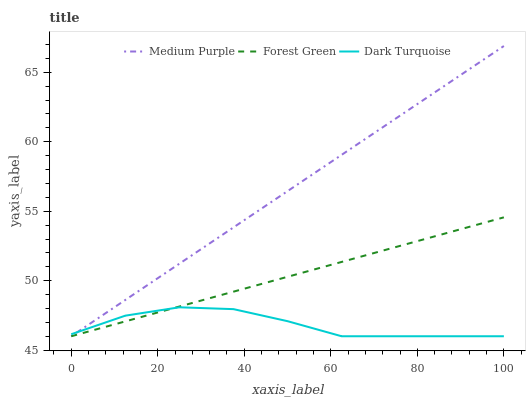Does Dark Turquoise have the minimum area under the curve?
Answer yes or no. Yes. Does Medium Purple have the maximum area under the curve?
Answer yes or no. Yes. Does Forest Green have the minimum area under the curve?
Answer yes or no. No. Does Forest Green have the maximum area under the curve?
Answer yes or no. No. Is Forest Green the smoothest?
Answer yes or no. Yes. Is Dark Turquoise the roughest?
Answer yes or no. Yes. Is Dark Turquoise the smoothest?
Answer yes or no. No. Is Forest Green the roughest?
Answer yes or no. No. Does Medium Purple have the lowest value?
Answer yes or no. Yes. Does Medium Purple have the highest value?
Answer yes or no. Yes. Does Forest Green have the highest value?
Answer yes or no. No. Does Medium Purple intersect Dark Turquoise?
Answer yes or no. Yes. Is Medium Purple less than Dark Turquoise?
Answer yes or no. No. Is Medium Purple greater than Dark Turquoise?
Answer yes or no. No. 